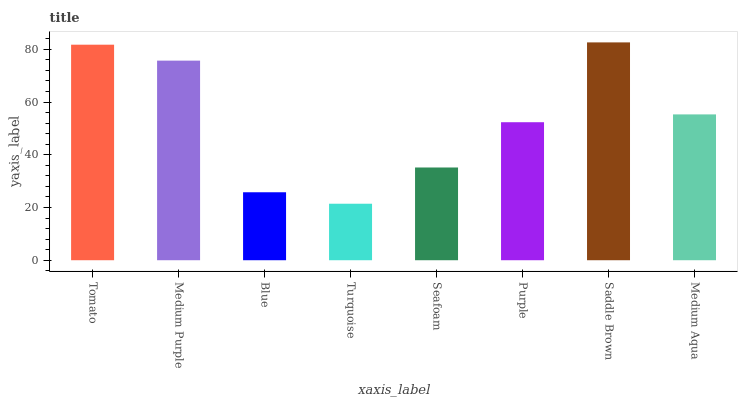Is Medium Purple the minimum?
Answer yes or no. No. Is Medium Purple the maximum?
Answer yes or no. No. Is Tomato greater than Medium Purple?
Answer yes or no. Yes. Is Medium Purple less than Tomato?
Answer yes or no. Yes. Is Medium Purple greater than Tomato?
Answer yes or no. No. Is Tomato less than Medium Purple?
Answer yes or no. No. Is Medium Aqua the high median?
Answer yes or no. Yes. Is Purple the low median?
Answer yes or no. Yes. Is Tomato the high median?
Answer yes or no. No. Is Tomato the low median?
Answer yes or no. No. 